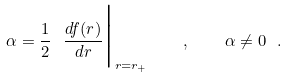<formula> <loc_0><loc_0><loc_500><loc_500>\alpha = \frac { 1 } { 2 } \ \frac { d f ( r ) } { d r } \Big | _ { r = r _ { + } } \quad , \quad \alpha \neq 0 \ .</formula> 